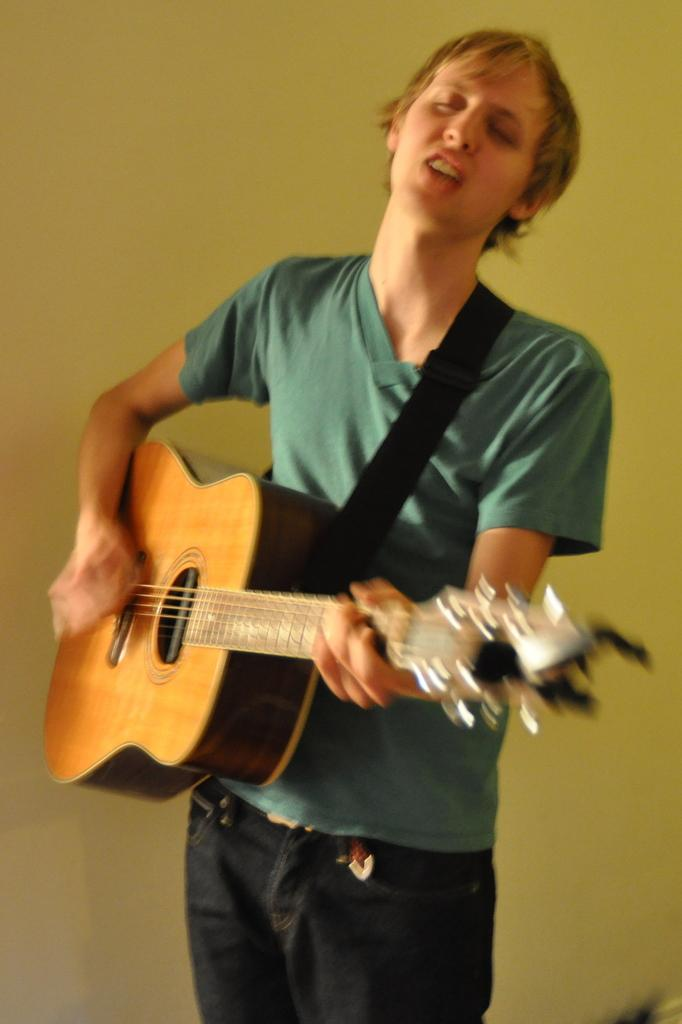What is the main subject of the image? There is a man in the image. What is the man doing in the image? The man is standing in the image. What is the man holding in the image? The man is holding a music instrument in the image. What color is the music instrument? The music instrument is yellow. What can be seen in the background of the image? There is a yellow color wall in the background of the image. Can you see any fog in the image? There is no fog visible in the image. 